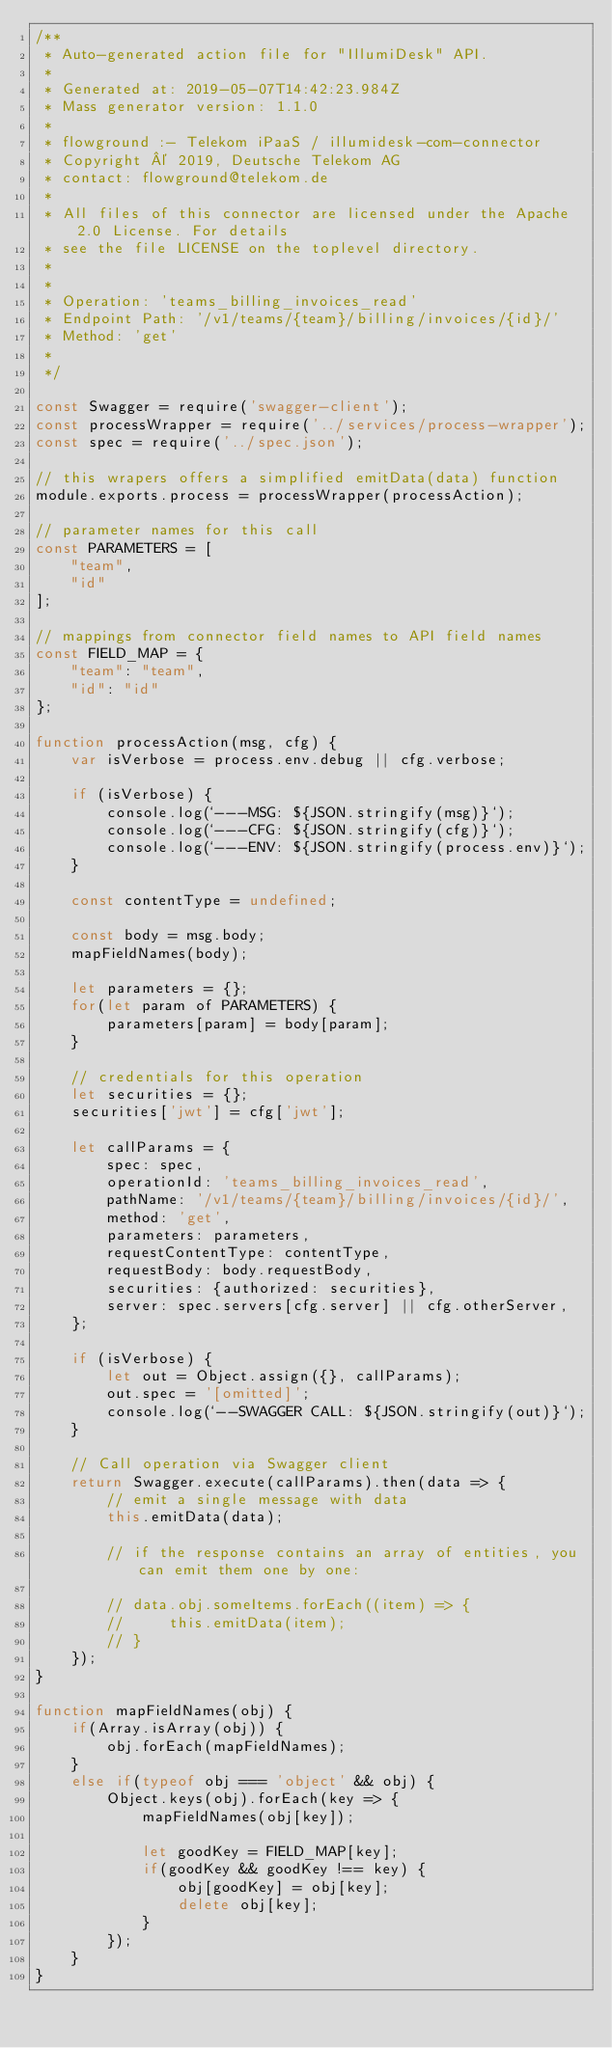<code> <loc_0><loc_0><loc_500><loc_500><_JavaScript_>/**
 * Auto-generated action file for "IllumiDesk" API.
 *
 * Generated at: 2019-05-07T14:42:23.984Z
 * Mass generator version: 1.1.0
 *
 * flowground :- Telekom iPaaS / illumidesk-com-connector
 * Copyright © 2019, Deutsche Telekom AG
 * contact: flowground@telekom.de
 *
 * All files of this connector are licensed under the Apache 2.0 License. For details
 * see the file LICENSE on the toplevel directory.
 *
 *
 * Operation: 'teams_billing_invoices_read'
 * Endpoint Path: '/v1/teams/{team}/billing/invoices/{id}/'
 * Method: 'get'
 *
 */

const Swagger = require('swagger-client');
const processWrapper = require('../services/process-wrapper');
const spec = require('../spec.json');

// this wrapers offers a simplified emitData(data) function
module.exports.process = processWrapper(processAction);

// parameter names for this call
const PARAMETERS = [
    "team",
    "id"
];

// mappings from connector field names to API field names
const FIELD_MAP = {
    "team": "team",
    "id": "id"
};

function processAction(msg, cfg) {
    var isVerbose = process.env.debug || cfg.verbose;

    if (isVerbose) {
        console.log(`---MSG: ${JSON.stringify(msg)}`);
        console.log(`---CFG: ${JSON.stringify(cfg)}`);
        console.log(`---ENV: ${JSON.stringify(process.env)}`);
    }

    const contentType = undefined;

    const body = msg.body;
    mapFieldNames(body);

    let parameters = {};
    for(let param of PARAMETERS) {
        parameters[param] = body[param];
    }

    // credentials for this operation
    let securities = {};
    securities['jwt'] = cfg['jwt'];

    let callParams = {
        spec: spec,
        operationId: 'teams_billing_invoices_read',
        pathName: '/v1/teams/{team}/billing/invoices/{id}/',
        method: 'get',
        parameters: parameters,
        requestContentType: contentType,
        requestBody: body.requestBody,
        securities: {authorized: securities},
        server: spec.servers[cfg.server] || cfg.otherServer,
    };

    if (isVerbose) {
        let out = Object.assign({}, callParams);
        out.spec = '[omitted]';
        console.log(`--SWAGGER CALL: ${JSON.stringify(out)}`);
    }

    // Call operation via Swagger client
    return Swagger.execute(callParams).then(data => {
        // emit a single message with data
        this.emitData(data);

        // if the response contains an array of entities, you can emit them one by one:

        // data.obj.someItems.forEach((item) => {
        //     this.emitData(item);
        // }
    });
}

function mapFieldNames(obj) {
    if(Array.isArray(obj)) {
        obj.forEach(mapFieldNames);
    }
    else if(typeof obj === 'object' && obj) {
        Object.keys(obj).forEach(key => {
            mapFieldNames(obj[key]);

            let goodKey = FIELD_MAP[key];
            if(goodKey && goodKey !== key) {
                obj[goodKey] = obj[key];
                delete obj[key];
            }
        });
    }
}</code> 